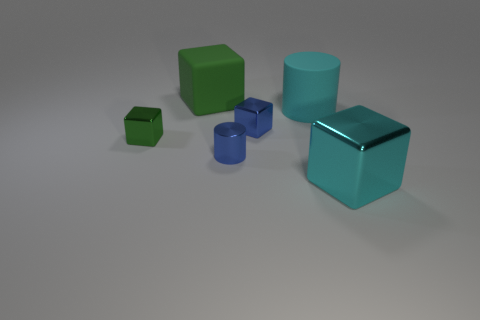Subtract all green cubes. Subtract all red spheres. How many cubes are left? 2 Add 2 purple spheres. How many objects exist? 8 Subtract all blocks. How many objects are left? 2 Add 2 tiny purple rubber blocks. How many tiny purple rubber blocks exist? 2 Subtract 0 green cylinders. How many objects are left? 6 Subtract all rubber blocks. Subtract all green cubes. How many objects are left? 3 Add 1 cyan shiny blocks. How many cyan shiny blocks are left? 2 